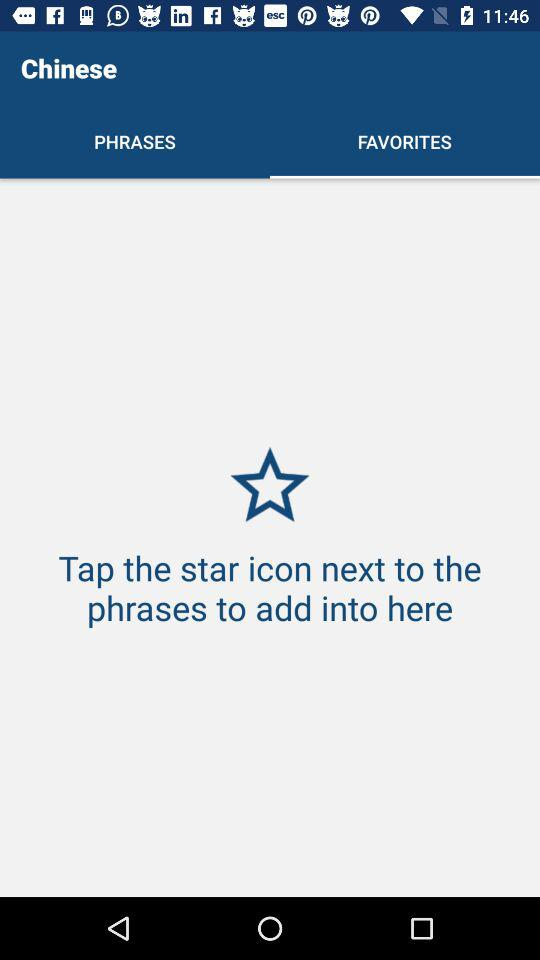Which tab is selected? The selected tab is "FAVORITES". 